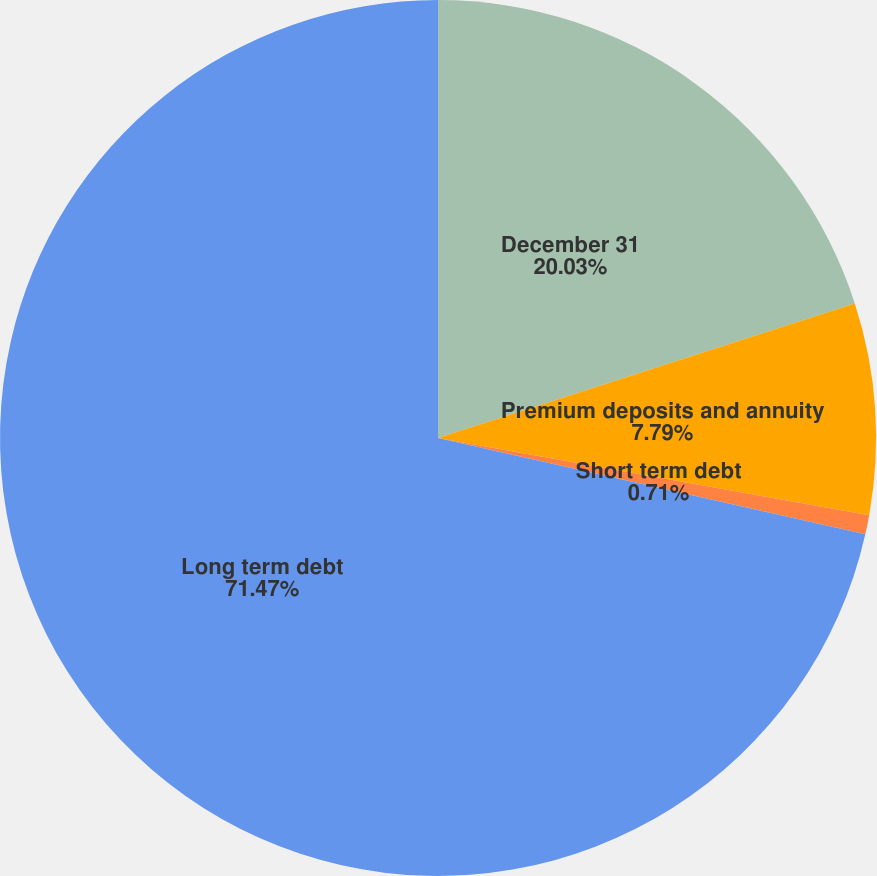Convert chart. <chart><loc_0><loc_0><loc_500><loc_500><pie_chart><fcel>December 31<fcel>Premium deposits and annuity<fcel>Short term debt<fcel>Long term debt<nl><fcel>20.03%<fcel>7.79%<fcel>0.71%<fcel>71.48%<nl></chart> 